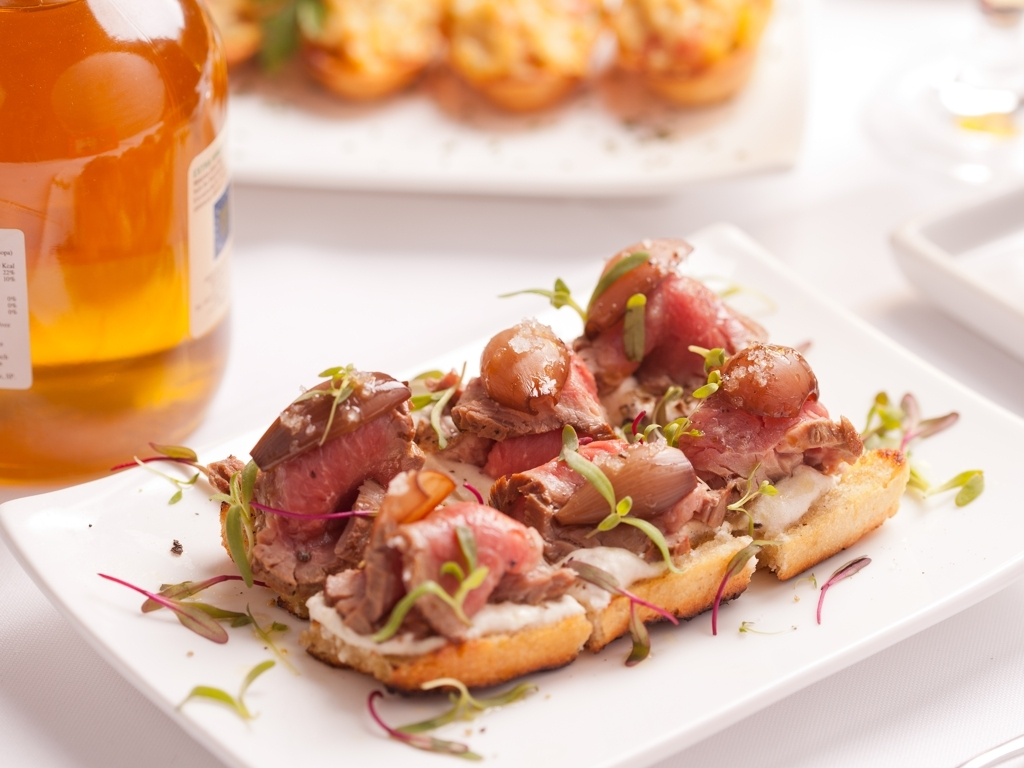What type of cuisine is featured in this image? The image features a fine dining presentation of what appears to be a type of crostini or bruschetta, topped with what could be roast beef or cured meat, marinated onions, and a garnish, possibly hinting at an Italian or European-inspired cuisine. 